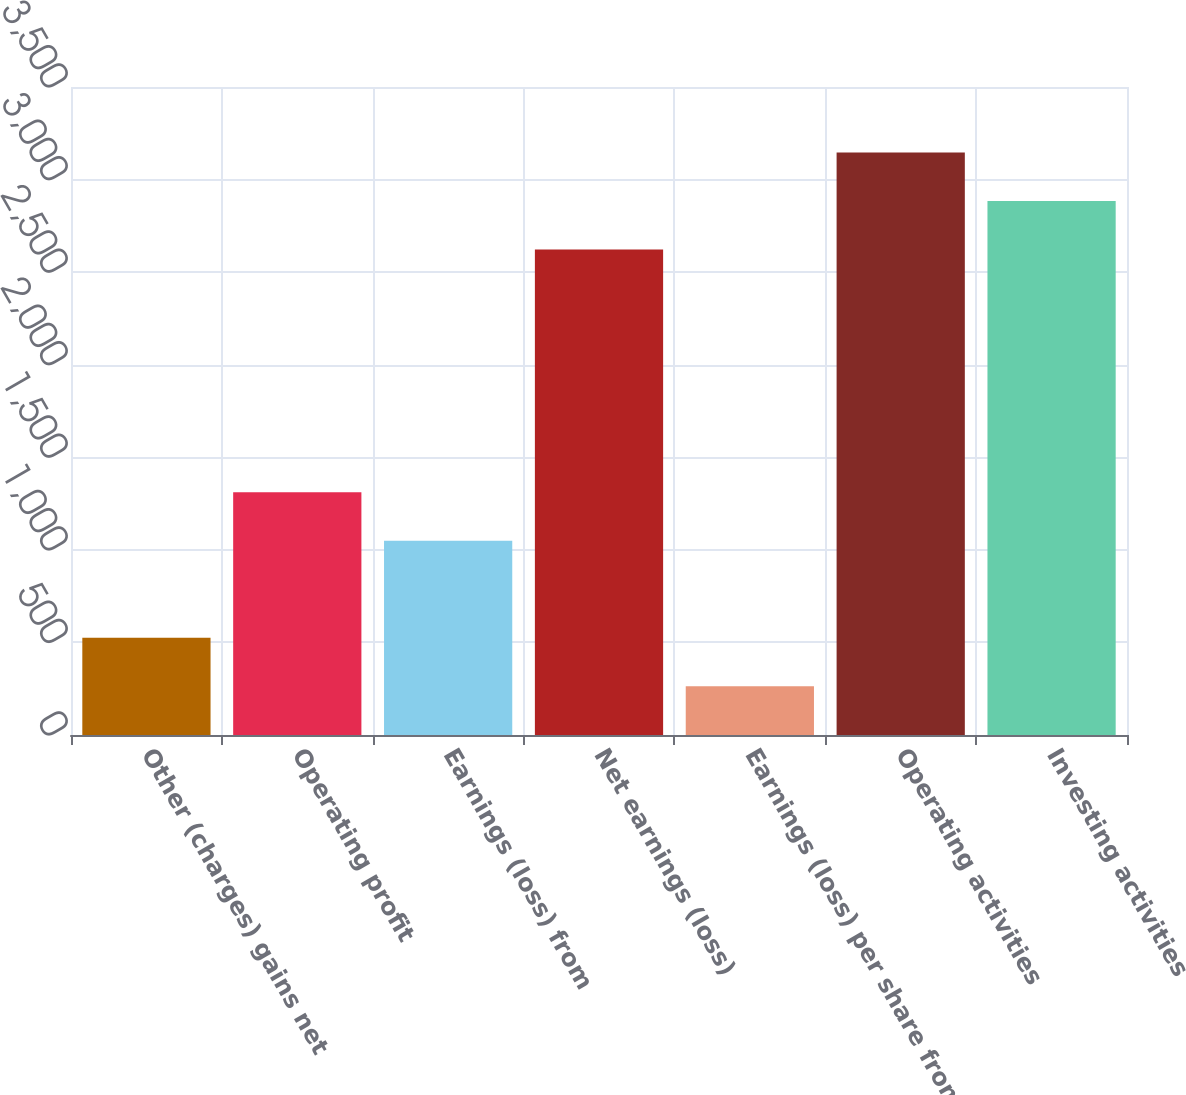Convert chart to OTSL. <chart><loc_0><loc_0><loc_500><loc_500><bar_chart><fcel>Other (charges) gains net<fcel>Operating profit<fcel>Earnings (loss) from<fcel>Net earnings (loss)<fcel>Earnings (loss) per share from<fcel>Operating activities<fcel>Investing activities<nl><fcel>525.17<fcel>1311.47<fcel>1049.37<fcel>2621.97<fcel>263.07<fcel>3146.17<fcel>2884.07<nl></chart> 